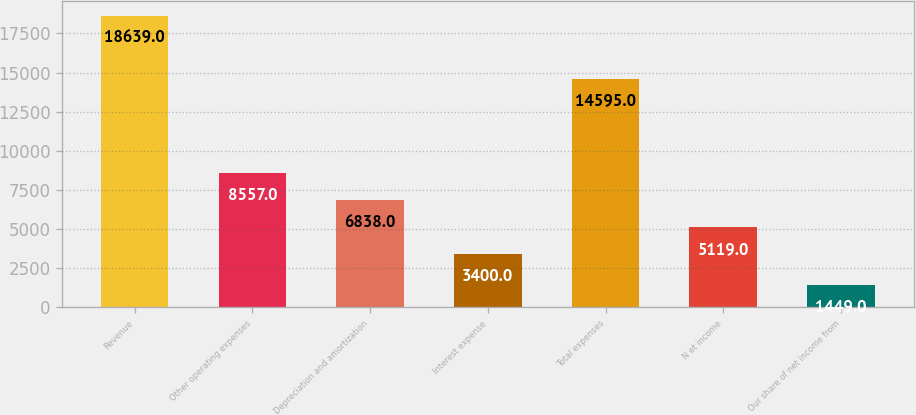<chart> <loc_0><loc_0><loc_500><loc_500><bar_chart><fcel>Revenue<fcel>Other operating expenses<fcel>Depreciation and amortization<fcel>Interest expense<fcel>Total expenses<fcel>N et income<fcel>Our share of net income from<nl><fcel>18639<fcel>8557<fcel>6838<fcel>3400<fcel>14595<fcel>5119<fcel>1449<nl></chart> 